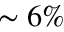Convert formula to latex. <formula><loc_0><loc_0><loc_500><loc_500>\sim 6 \%</formula> 